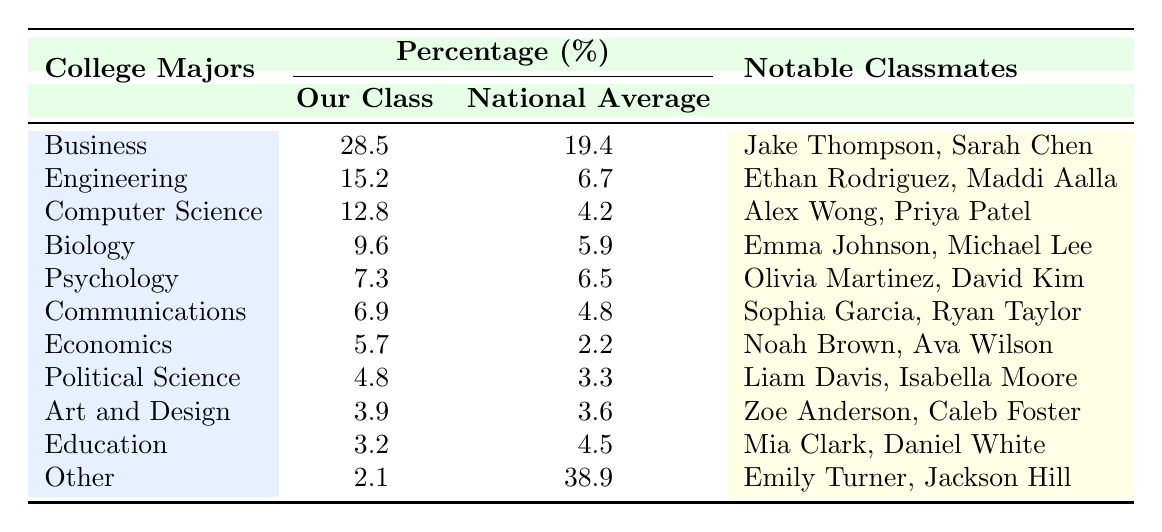What percentage of our class chose a major in Business? According to the table, the percentage of our class that chose Business as their major is listed under "Our Class" for Business, which is 28.5%.
Answer: 28.5% What is the national average percentage for Engineering majors? The national average percentage for Engineering majors is provided directly in the table under "National Average" for Engineering, which is 6.7%.
Answer: 6.7% Which major has the highest percentage in our class? By examining the percentages listed in "Our Class," Business has the highest percentage at 28.5%.
Answer: Business Is the percentage of Psychology majors in our class higher than the national average? The table shows that our class has a percentage of 7.3% for Psychology, while the national average is 6.5%. Since 7.3% is greater than 6.5%, the answer is yes.
Answer: Yes What is the difference in percentage between our class and the national average for Computer Science majors? Our class has 12.8% for Computer Science, and the national average is 4.2%. The difference is calculated as 12.8% - 4.2% = 8.6%.
Answer: 8.6% Which major has a lower percentage in our class compared to the national average? Looking at the table, Education has 3.2% in our class while the national average is 4.5%, indicating it is lower.
Answer: Education What is the total percentage of majors that exceed the national average? We sum the percentages of Business (28.5), Engineering (15.2), Computer Science (12.8), Biology (9.6), Psychology (7.3), Communications (6.9), Economics (5.7), and Political Science (4.8), which are all higher than their national averages. The total is 28.5 + 15.2 + 12.8 + 9.6 + 7.3 + 6.9 + 5.7 + 4.8 = 90.8%.
Answer: 90.8% What percentage of our class chose "Other" as their major, and how does it compare to the national average? Our class chose "Other" at a percentage of 2.1%, while the national average is significantly higher at 38.9%. This indicates a stark contrast, as 2.1% is much lower than 38.9%.
Answer: 2.1% Are there more notable classmates listed from Computer Science or from Economics? The notable classmates for Computer Science are Alex Wong and Priya Patel (2 classmates), while for Economics, they are Noah Brown and Ava Wilson (2 classmates as well). Therefore, the number is equal.
Answer: Equal What major has the largest difference between our class's percentage and the national average? The largest percentage difference can be calculated for Business, which has a difference of 28.5% - 19.4% = 9.1%. No other major has a greater difference than this amount when compared.
Answer: Business 